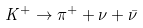<formula> <loc_0><loc_0><loc_500><loc_500>K ^ { + } \to \pi ^ { + } + \nu + \bar { \nu }</formula> 